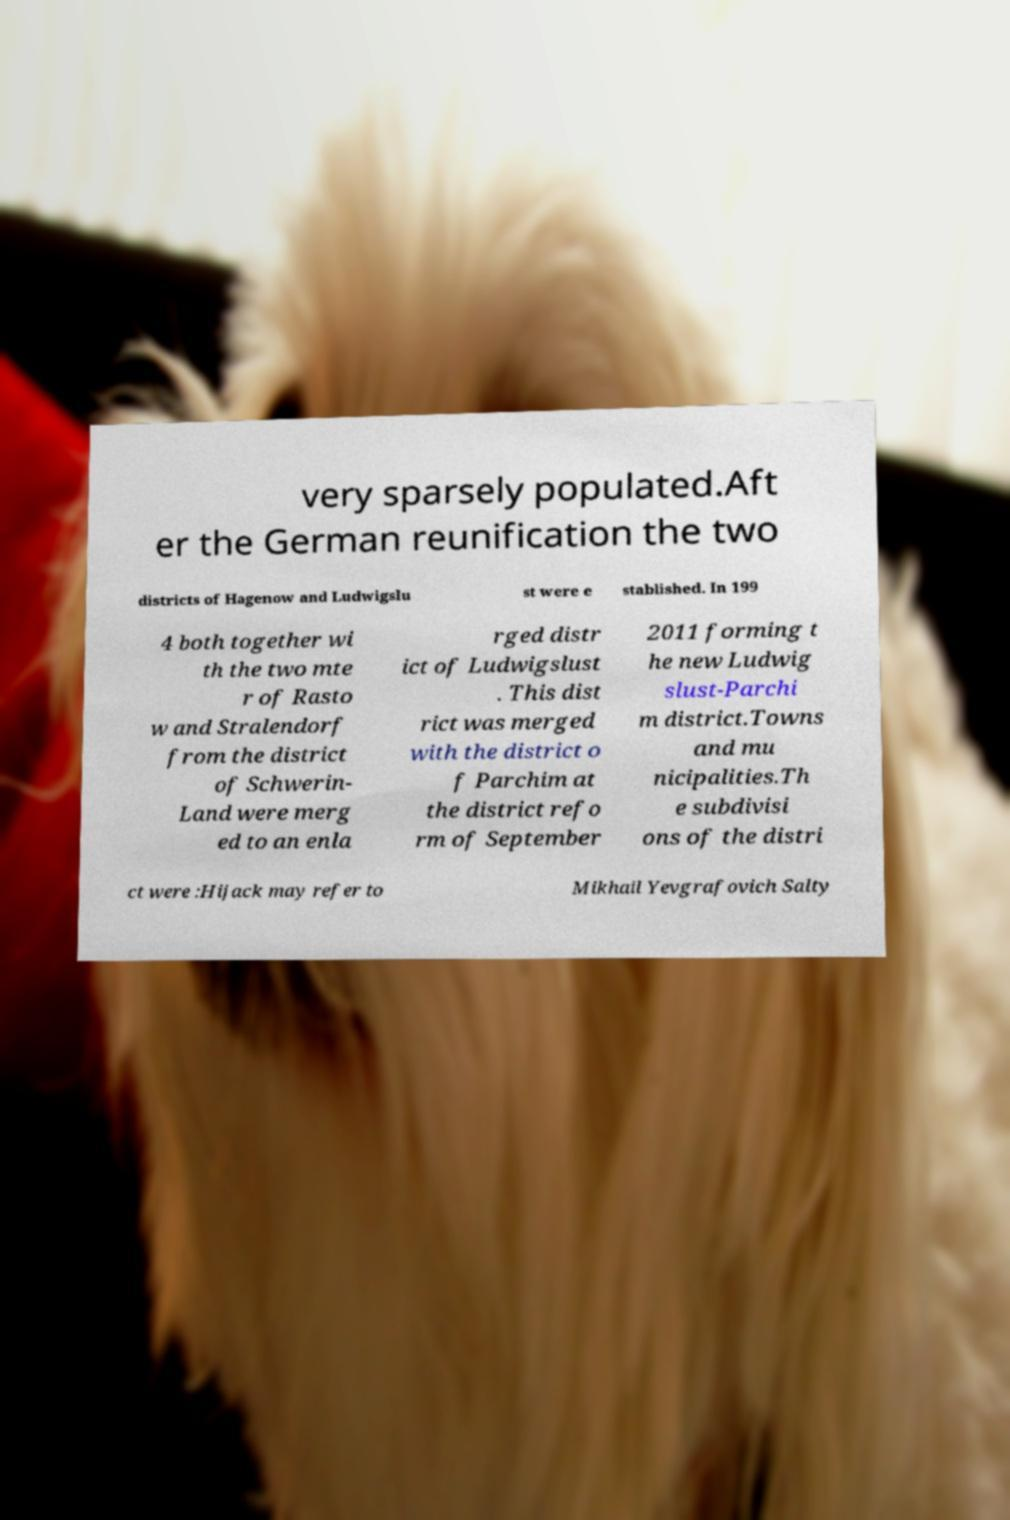I need the written content from this picture converted into text. Can you do that? very sparsely populated.Aft er the German reunification the two districts of Hagenow and Ludwigslu st were e stablished. In 199 4 both together wi th the two mte r of Rasto w and Stralendorf from the district of Schwerin- Land were merg ed to an enla rged distr ict of Ludwigslust . This dist rict was merged with the district o f Parchim at the district refo rm of September 2011 forming t he new Ludwig slust-Parchi m district.Towns and mu nicipalities.Th e subdivisi ons of the distri ct were :Hijack may refer to Mikhail Yevgrafovich Salty 